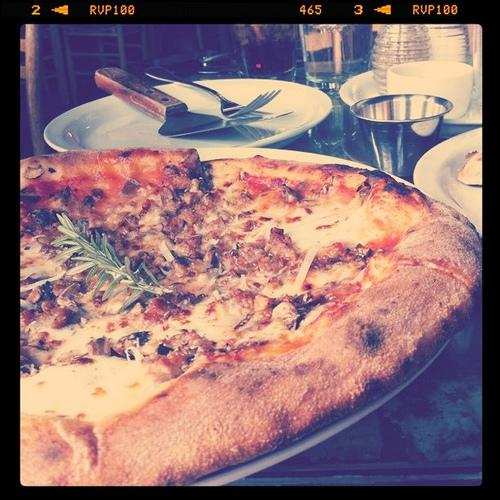Question: what is on the tray?
Choices:
A. Soda can.
B. Dinner.
C. Cookies.
D. Pizza.
Answer with the letter. Answer: D Question: where is the tray placed?
Choices:
A. Counter.
B. Sink.
C. Dining room.
D. Table.
Answer with the letter. Answer: D Question: who will eat the pizza?
Choices:
A. Children.
B. Couples.
C. Customers.
D. A family.
Answer with the letter. Answer: C Question: where is the spatula placed?
Choices:
A. In a pan.
B. In the sink.
C. Plate.
D. In the dishwasher.
Answer with the letter. Answer: C Question: what color is the crust?
Choices:
A. Black.
B. Orange.
C. Green.
D. Brown.
Answer with the letter. Answer: D 